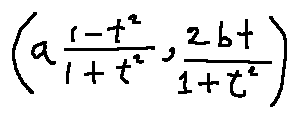Convert formula to latex. <formula><loc_0><loc_0><loc_500><loc_500>( a \frac { 1 - t ^ { 2 } } { 1 + t ^ { 2 } } , \frac { 2 b t } { 1 + t ^ { 2 } } )</formula> 